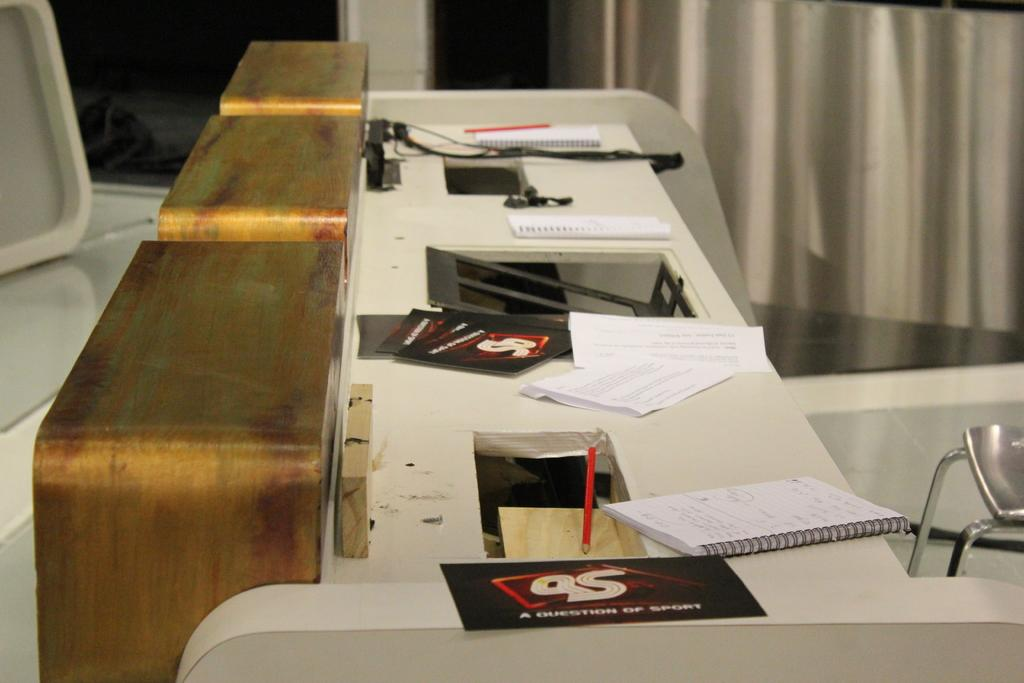What type of furniture can be seen in the image? There is a chair and a desk in the image. What is on top of the desk? Papers, files, boards, and pens are present on the desk. What might be used for writing or drawing on the boards? Pens are present on the desk, which could be used for writing or drawing on the boards. How many brothers are celebrating their birthday together in the image? There is no reference to a birthday or brothers in the image, so it is not possible to answer that question. 